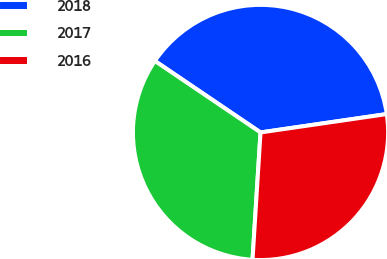Convert chart to OTSL. <chart><loc_0><loc_0><loc_500><loc_500><pie_chart><fcel>2018<fcel>2017<fcel>2016<nl><fcel>38.23%<fcel>33.47%<fcel>28.3%<nl></chart> 